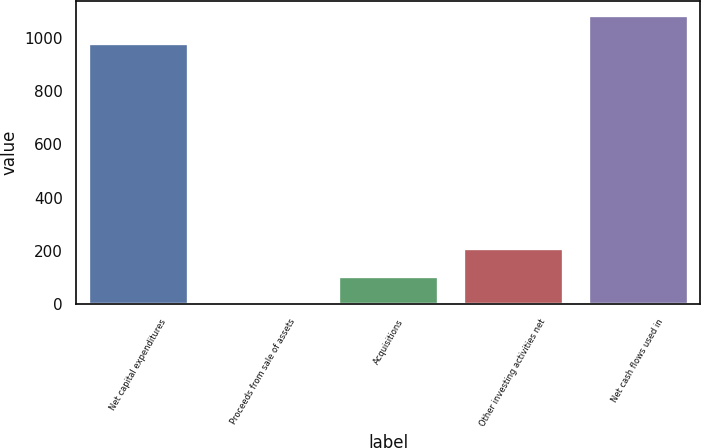Convert chart. <chart><loc_0><loc_0><loc_500><loc_500><bar_chart><fcel>Net capital expenditures<fcel>Proceeds from sale of assets<fcel>Acquisitions<fcel>Other investing activities net<fcel>Net cash flows used in<nl><fcel>980<fcel>1<fcel>106.2<fcel>211.4<fcel>1085.2<nl></chart> 